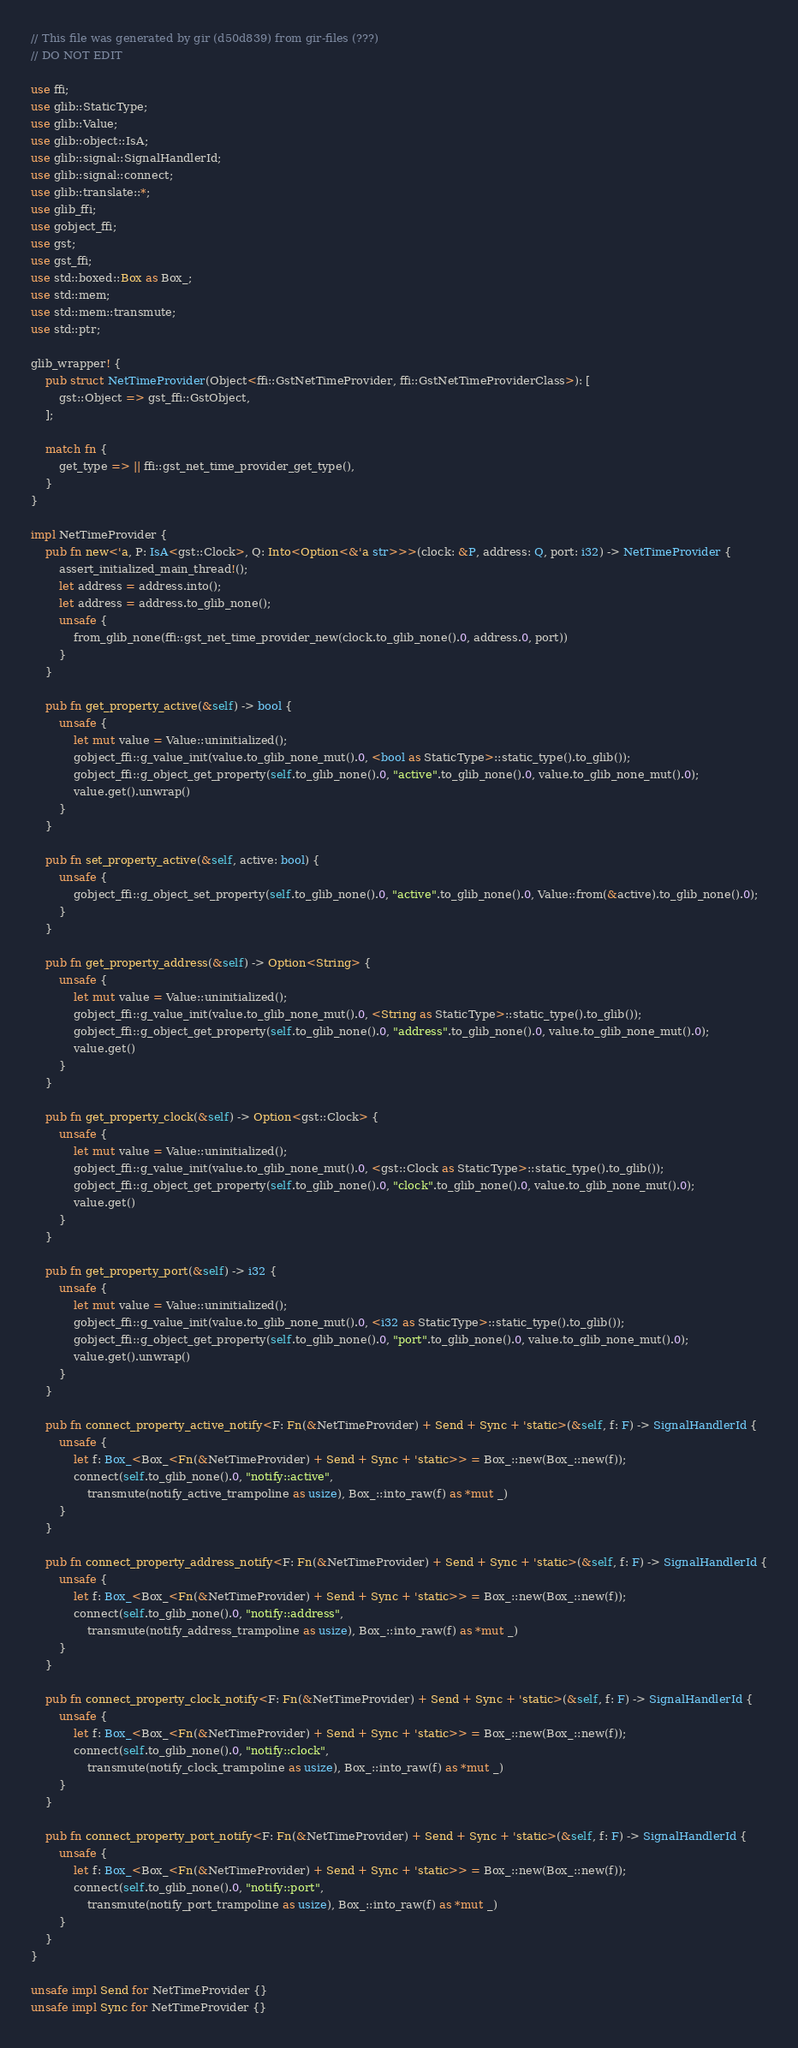<code> <loc_0><loc_0><loc_500><loc_500><_Rust_>// This file was generated by gir (d50d839) from gir-files (???)
// DO NOT EDIT

use ffi;
use glib::StaticType;
use glib::Value;
use glib::object::IsA;
use glib::signal::SignalHandlerId;
use glib::signal::connect;
use glib::translate::*;
use glib_ffi;
use gobject_ffi;
use gst;
use gst_ffi;
use std::boxed::Box as Box_;
use std::mem;
use std::mem::transmute;
use std::ptr;

glib_wrapper! {
    pub struct NetTimeProvider(Object<ffi::GstNetTimeProvider, ffi::GstNetTimeProviderClass>): [
        gst::Object => gst_ffi::GstObject,
    ];

    match fn {
        get_type => || ffi::gst_net_time_provider_get_type(),
    }
}

impl NetTimeProvider {
    pub fn new<'a, P: IsA<gst::Clock>, Q: Into<Option<&'a str>>>(clock: &P, address: Q, port: i32) -> NetTimeProvider {
        assert_initialized_main_thread!();
        let address = address.into();
        let address = address.to_glib_none();
        unsafe {
            from_glib_none(ffi::gst_net_time_provider_new(clock.to_glib_none().0, address.0, port))
        }
    }

    pub fn get_property_active(&self) -> bool {
        unsafe {
            let mut value = Value::uninitialized();
            gobject_ffi::g_value_init(value.to_glib_none_mut().0, <bool as StaticType>::static_type().to_glib());
            gobject_ffi::g_object_get_property(self.to_glib_none().0, "active".to_glib_none().0, value.to_glib_none_mut().0);
            value.get().unwrap()
        }
    }

    pub fn set_property_active(&self, active: bool) {
        unsafe {
            gobject_ffi::g_object_set_property(self.to_glib_none().0, "active".to_glib_none().0, Value::from(&active).to_glib_none().0);
        }
    }

    pub fn get_property_address(&self) -> Option<String> {
        unsafe {
            let mut value = Value::uninitialized();
            gobject_ffi::g_value_init(value.to_glib_none_mut().0, <String as StaticType>::static_type().to_glib());
            gobject_ffi::g_object_get_property(self.to_glib_none().0, "address".to_glib_none().0, value.to_glib_none_mut().0);
            value.get()
        }
    }

    pub fn get_property_clock(&self) -> Option<gst::Clock> {
        unsafe {
            let mut value = Value::uninitialized();
            gobject_ffi::g_value_init(value.to_glib_none_mut().0, <gst::Clock as StaticType>::static_type().to_glib());
            gobject_ffi::g_object_get_property(self.to_glib_none().0, "clock".to_glib_none().0, value.to_glib_none_mut().0);
            value.get()
        }
    }

    pub fn get_property_port(&self) -> i32 {
        unsafe {
            let mut value = Value::uninitialized();
            gobject_ffi::g_value_init(value.to_glib_none_mut().0, <i32 as StaticType>::static_type().to_glib());
            gobject_ffi::g_object_get_property(self.to_glib_none().0, "port".to_glib_none().0, value.to_glib_none_mut().0);
            value.get().unwrap()
        }
    }

    pub fn connect_property_active_notify<F: Fn(&NetTimeProvider) + Send + Sync + 'static>(&self, f: F) -> SignalHandlerId {
        unsafe {
            let f: Box_<Box_<Fn(&NetTimeProvider) + Send + Sync + 'static>> = Box_::new(Box_::new(f));
            connect(self.to_glib_none().0, "notify::active",
                transmute(notify_active_trampoline as usize), Box_::into_raw(f) as *mut _)
        }
    }

    pub fn connect_property_address_notify<F: Fn(&NetTimeProvider) + Send + Sync + 'static>(&self, f: F) -> SignalHandlerId {
        unsafe {
            let f: Box_<Box_<Fn(&NetTimeProvider) + Send + Sync + 'static>> = Box_::new(Box_::new(f));
            connect(self.to_glib_none().0, "notify::address",
                transmute(notify_address_trampoline as usize), Box_::into_raw(f) as *mut _)
        }
    }

    pub fn connect_property_clock_notify<F: Fn(&NetTimeProvider) + Send + Sync + 'static>(&self, f: F) -> SignalHandlerId {
        unsafe {
            let f: Box_<Box_<Fn(&NetTimeProvider) + Send + Sync + 'static>> = Box_::new(Box_::new(f));
            connect(self.to_glib_none().0, "notify::clock",
                transmute(notify_clock_trampoline as usize), Box_::into_raw(f) as *mut _)
        }
    }

    pub fn connect_property_port_notify<F: Fn(&NetTimeProvider) + Send + Sync + 'static>(&self, f: F) -> SignalHandlerId {
        unsafe {
            let f: Box_<Box_<Fn(&NetTimeProvider) + Send + Sync + 'static>> = Box_::new(Box_::new(f));
            connect(self.to_glib_none().0, "notify::port",
                transmute(notify_port_trampoline as usize), Box_::into_raw(f) as *mut _)
        }
    }
}

unsafe impl Send for NetTimeProvider {}
unsafe impl Sync for NetTimeProvider {}
</code> 